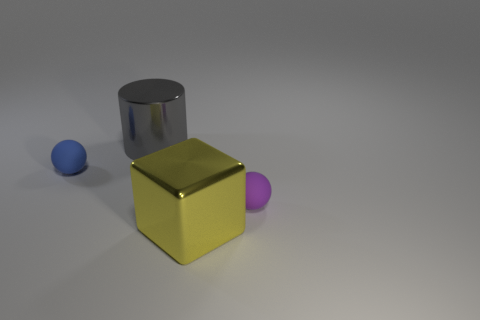There is a matte ball that is to the right of the matte ball on the left side of the tiny purple rubber thing; how many metallic cylinders are in front of it?
Give a very brief answer. 0. The gray shiny object is what shape?
Keep it short and to the point. Cylinder. How many yellow cubes are made of the same material as the blue object?
Offer a terse response. 0. The large thing that is the same material as the cylinder is what color?
Keep it short and to the point. Yellow. Does the purple rubber object have the same size as the metallic object behind the big yellow shiny object?
Provide a short and direct response. No. The object that is behind the small object to the left of the sphere that is to the right of the yellow metal cube is made of what material?
Keep it short and to the point. Metal. What number of things are small red spheres or tiny purple objects?
Your answer should be compact. 1. Does the rubber ball on the left side of the yellow metallic block have the same color as the thing to the right of the big cube?
Your answer should be very brief. No. The other rubber object that is the same size as the blue matte thing is what shape?
Make the answer very short. Sphere. How many objects are either big objects that are on the left side of the big yellow block or objects behind the tiny blue rubber object?
Keep it short and to the point. 1. 